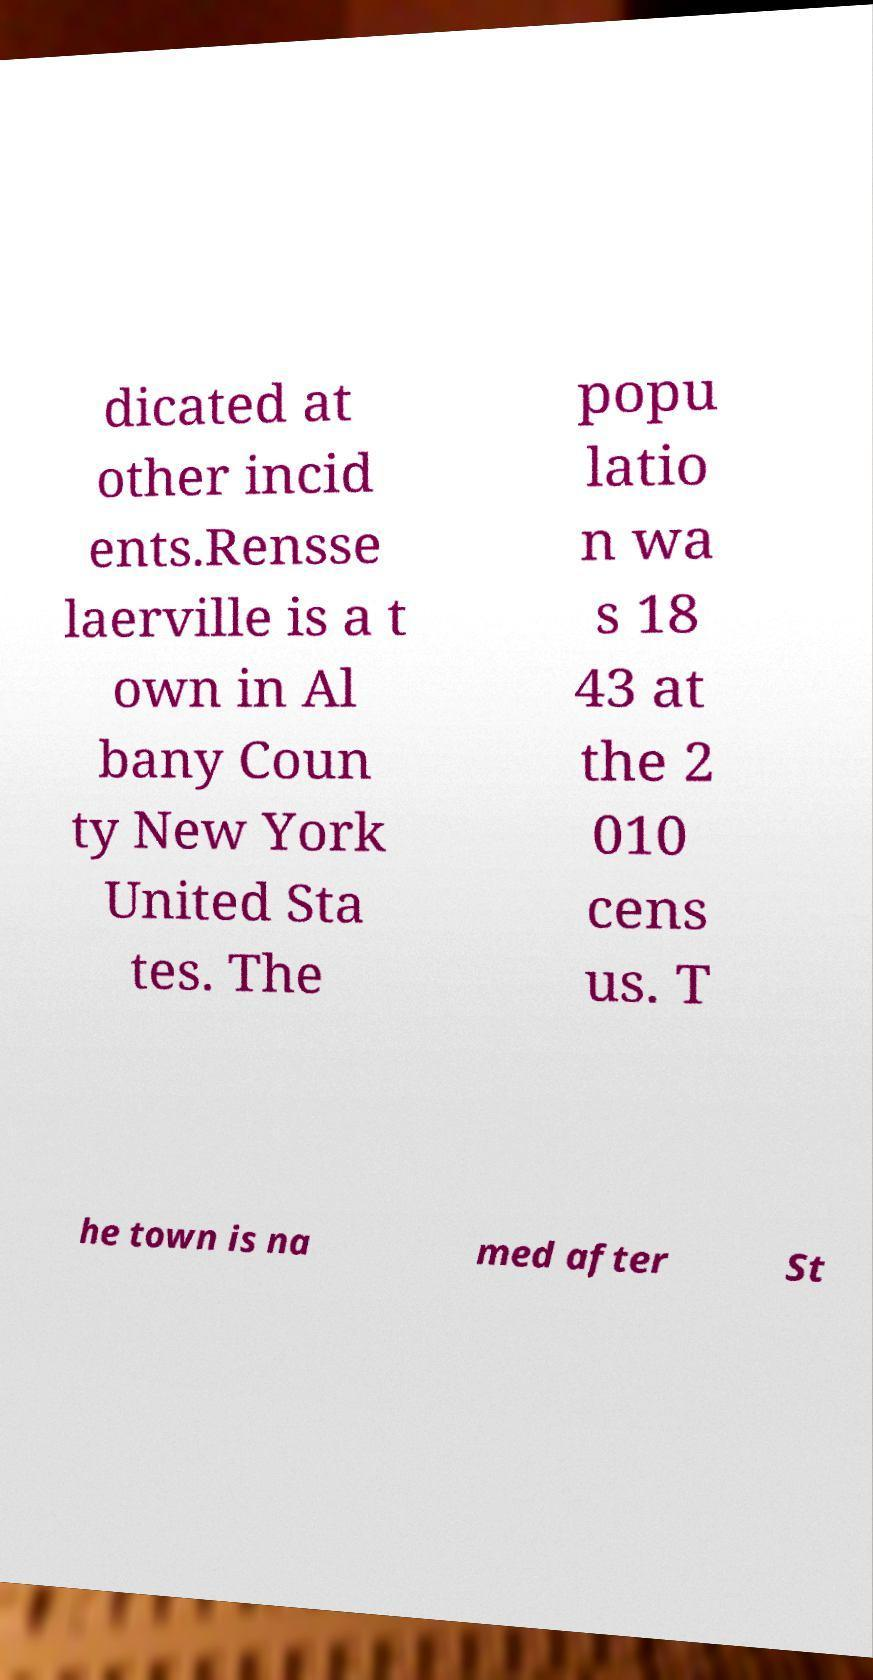For documentation purposes, I need the text within this image transcribed. Could you provide that? dicated at other incid ents.Rensse laerville is a t own in Al bany Coun ty New York United Sta tes. The popu latio n wa s 18 43 at the 2 010 cens us. T he town is na med after St 